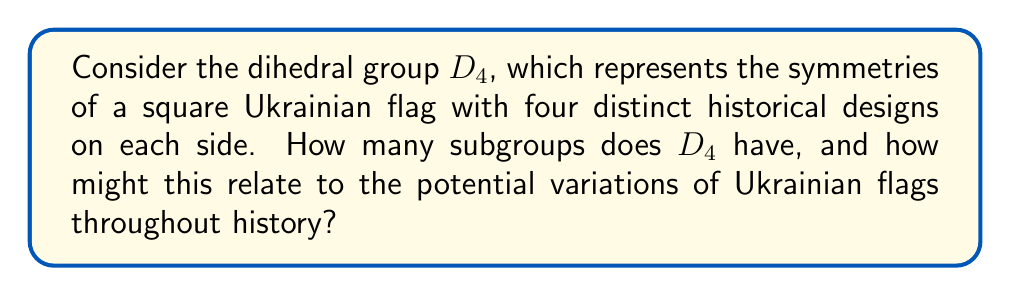Can you solve this math problem? To solve this problem, let's approach it step-by-step:

1) First, recall that the dihedral group $D_4$ has order 8. It consists of 4 rotations (including the identity) and 4 reflections.

2) To find the subgroups, we need to consider all possible combinations of these elements that form valid subgroups. Let's list them:

   a) The trivial subgroup: $\{e\}$ (order 1)
   b) The whole group: $D_4$ (order 8)
   c) The rotation subgroup: $\{e, r, r^2, r^3\}$ (order 4)
   d) Two reflection subgroups: $\{e, s\}$, $\{e, s'\}$ (each of order 2)
   e) Two diagonal reflection subgroups: $\{e, rs\}$, $\{e, r^3s\}$ (each of order 2)
   f) Three rotation subgroups: $\{e, r^2\}$, $\{e, rs^2\}$, $\{e, r^3s^2\}$ (each of order 2)

3) Counting these subgroups:
   1 (trivial) + 1 (whole group) + 1 (rotation) + 2 (reflections) + 2 (diagonal reflections) + 3 (rotation of order 2) = 10

4) From a historical perspective, this mathematical structure could represent:
   - The trivial subgroup: Ukraine before its distinct national identity
   - The whole group: The full spectrum of Ukrainian historical flags
   - The rotation subgroup: Major historical periods in Ukrainian history (e.g., Kievan Rus, Cossack era, Soviet period, modern independence)
   - Reflection and diagonal reflection subgroups: Specific historical flags or symbols
   - Rotation subgroups of order 2: Significant political transitions or revolutions in Ukrainian history

This mathematical structure provides a framework for analyzing the evolution and variations of Ukrainian flags throughout history, reflecting the complex political and cultural changes the country has undergone.
Answer: The dihedral group $D_4$ has 10 subgroups, which can be interpreted as representing different historical stages and variations of Ukrainian flags throughout its rich political history. 